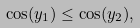<formula> <loc_0><loc_0><loc_500><loc_500>\cos ( y _ { 1 } ) \leq \cos ( y _ { 2 } ) ,</formula> 